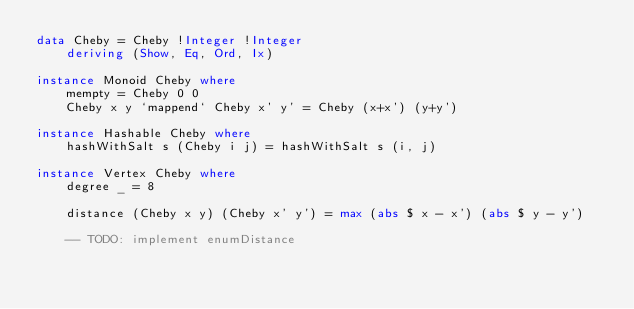Convert code to text. <code><loc_0><loc_0><loc_500><loc_500><_Haskell_>data Cheby = Cheby !Integer !Integer
    deriving (Show, Eq, Ord, Ix)

instance Monoid Cheby where
    mempty = Cheby 0 0
    Cheby x y `mappend` Cheby x' y' = Cheby (x+x') (y+y')

instance Hashable Cheby where
    hashWithSalt s (Cheby i j) = hashWithSalt s (i, j)

instance Vertex Cheby where
    degree _ = 8

    distance (Cheby x y) (Cheby x' y') = max (abs $ x - x') (abs $ y - y')

    -- TODO: implement enumDistance

</code> 